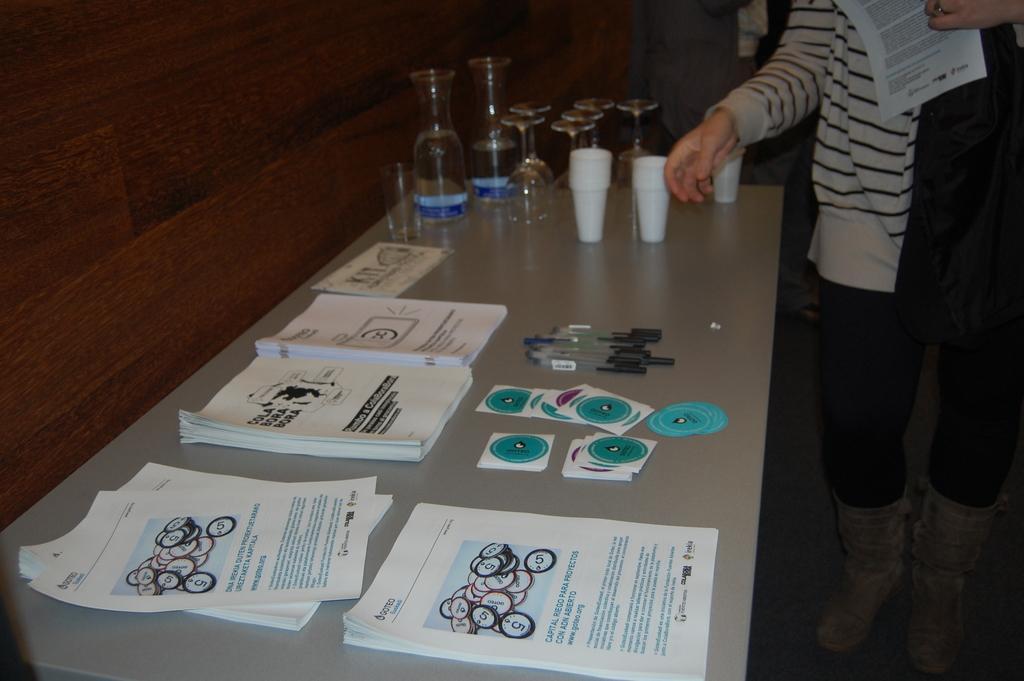Could you give a brief overview of what you see in this image? There is a table where there are papers in bundle and few stickers with pens and and glasses on it. And a person beside that. 